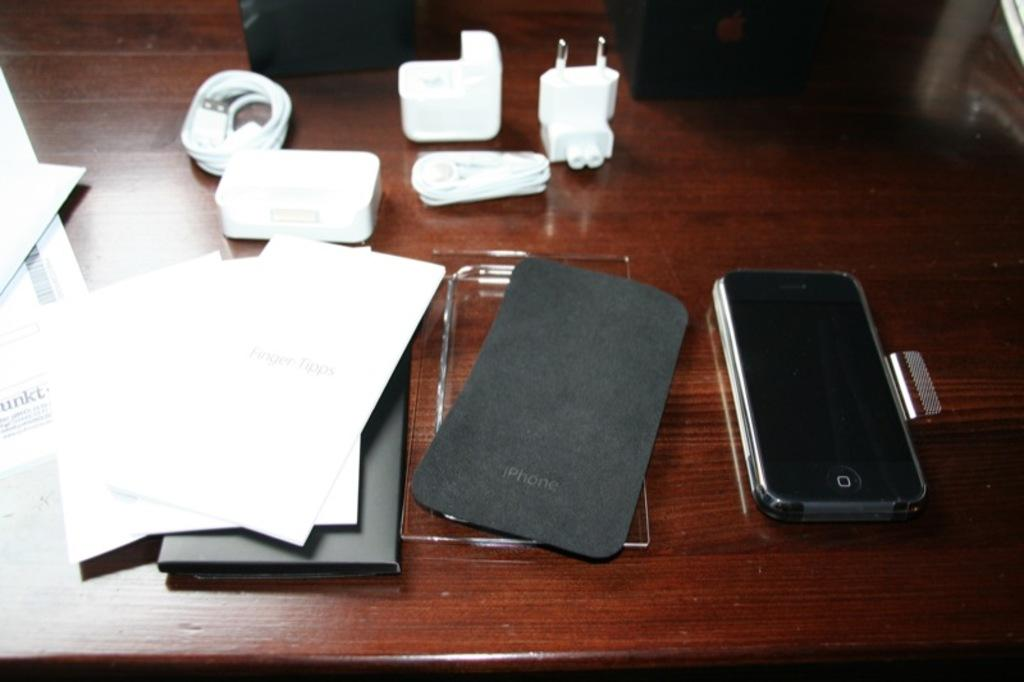<image>
Summarize the visual content of the image. A messy desktop with a corner of paper that reads unkt. 